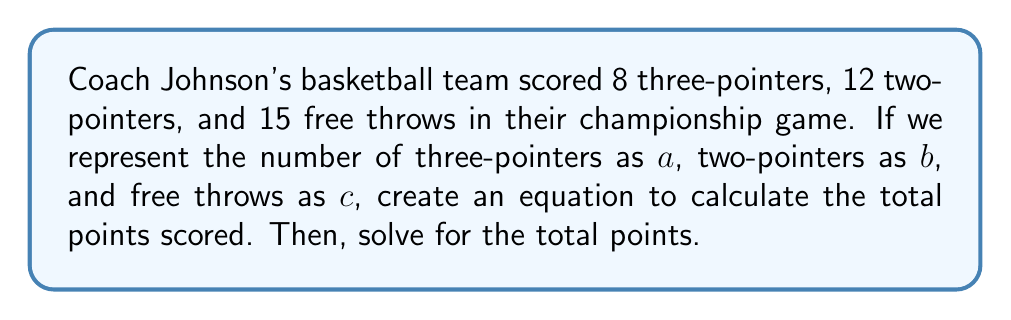Solve this math problem. Let's approach this step-by-step:

1) First, we need to understand the point value of each type of shot:
   - Three-pointers are worth 3 points each
   - Two-pointers are worth 2 points each
   - Free throws are worth 1 point each

2) Now, let's create our equation using the variables given:
   $$ \text{Total Points} = 3a + 2b + c $$

3) We know the values for each variable:
   $a = 8$ (three-pointers)
   $b = 12$ (two-pointers)
   $c = 15$ (free throws)

4) Let's substitute these values into our equation:
   $$ \text{Total Points} = 3(8) + 2(12) + 15 $$

5) Now, let's solve:
   $$ \text{Total Points} = 24 + 24 + 15 $$
   $$ \text{Total Points} = 63 $$

Therefore, Coach Johnson's team scored a total of 63 points in the championship game.
Answer: 63 points 